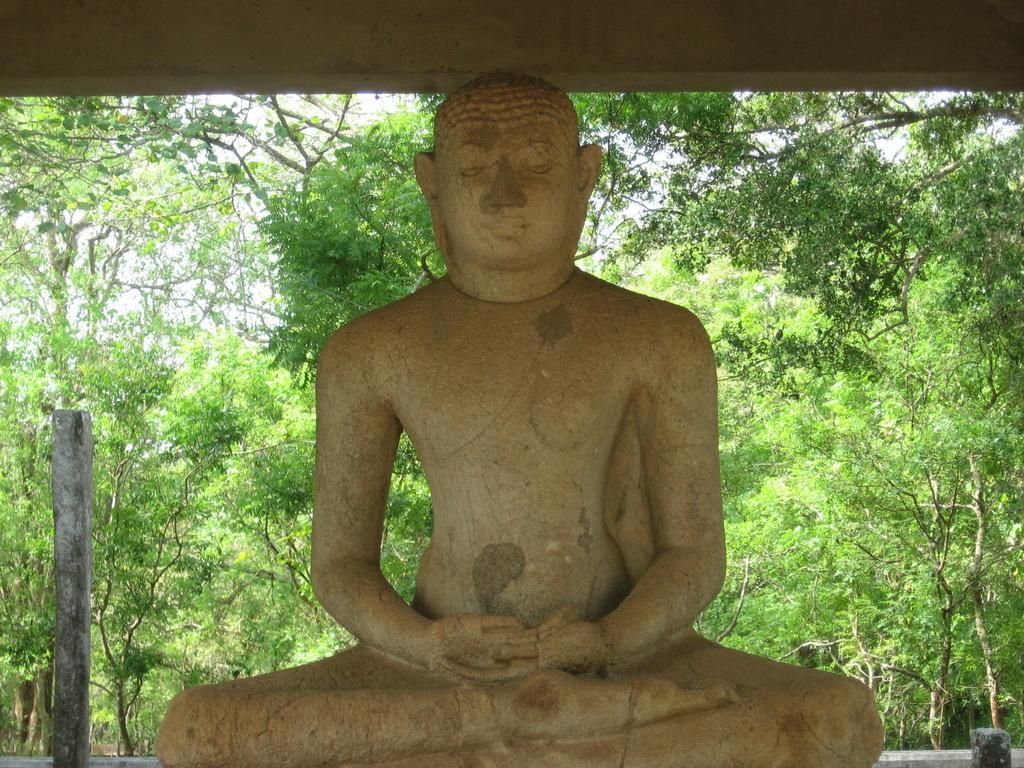Please provide a concise description of this image. In this image I can see a sculpture of a person. In the background there are some trees. On the left side, I can see a pillar. 